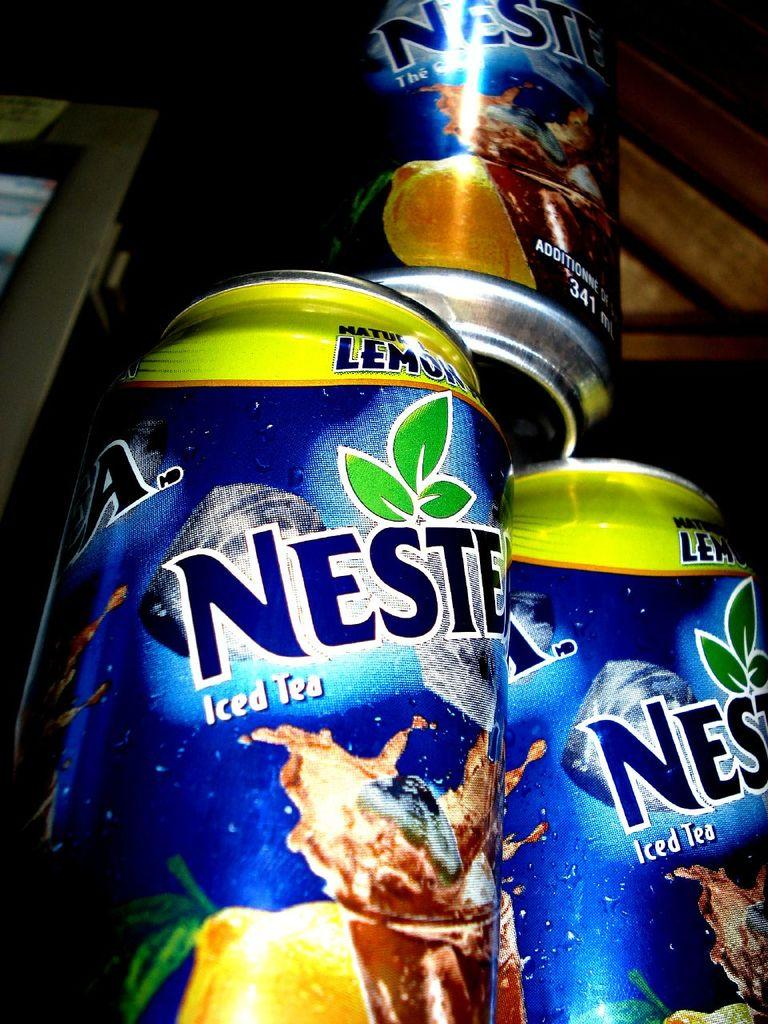<image>
Summarize the visual content of the image. Cans of Nestea iced tea that include natural lemon. 